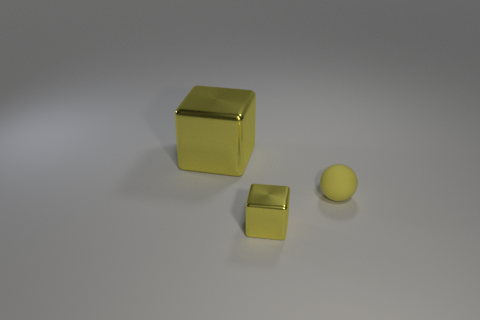Add 2 tiny green blocks. How many objects exist? 5 Subtract all cubes. How many objects are left? 1 Subtract all tiny yellow spheres. Subtract all metallic objects. How many objects are left? 0 Add 3 large yellow objects. How many large yellow objects are left? 4 Add 2 small shiny cubes. How many small shiny cubes exist? 3 Subtract 0 green spheres. How many objects are left? 3 